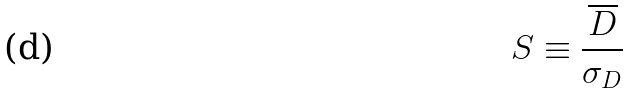<formula> <loc_0><loc_0><loc_500><loc_500>S \equiv \frac { \overline { D } } { \sigma _ { D } }</formula> 